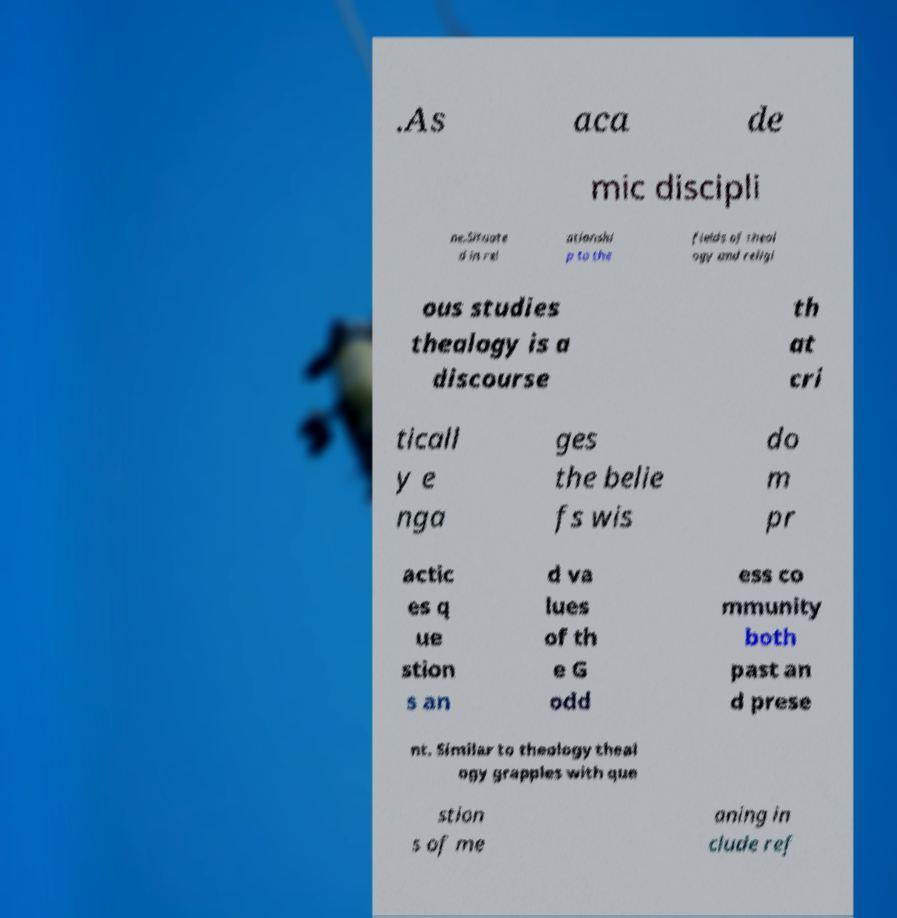What messages or text are displayed in this image? I need them in a readable, typed format. .As aca de mic discipli ne.Situate d in rel ationshi p to the fields of theol ogy and religi ous studies thealogy is a discourse th at cri ticall y e nga ges the belie fs wis do m pr actic es q ue stion s an d va lues of th e G odd ess co mmunity both past an d prese nt. Similar to theology theal ogy grapples with que stion s of me aning in clude ref 